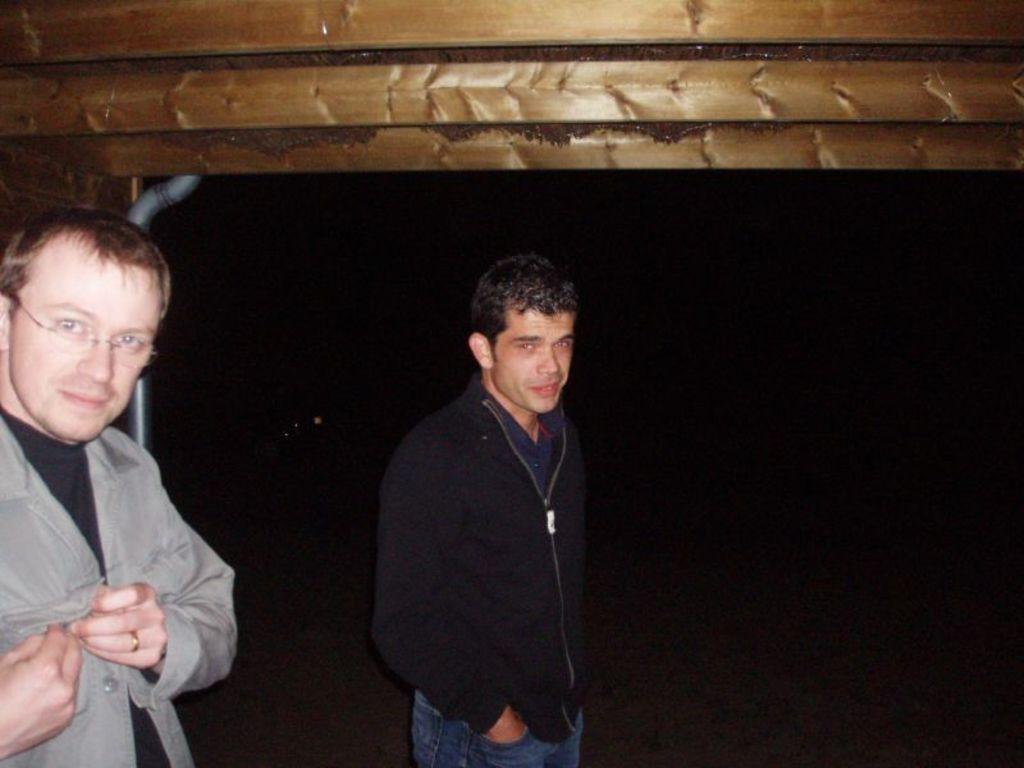Can you describe this image briefly? In this image we can see two men standing on the ground. In the background, we can see a pipe and wooden surface. 